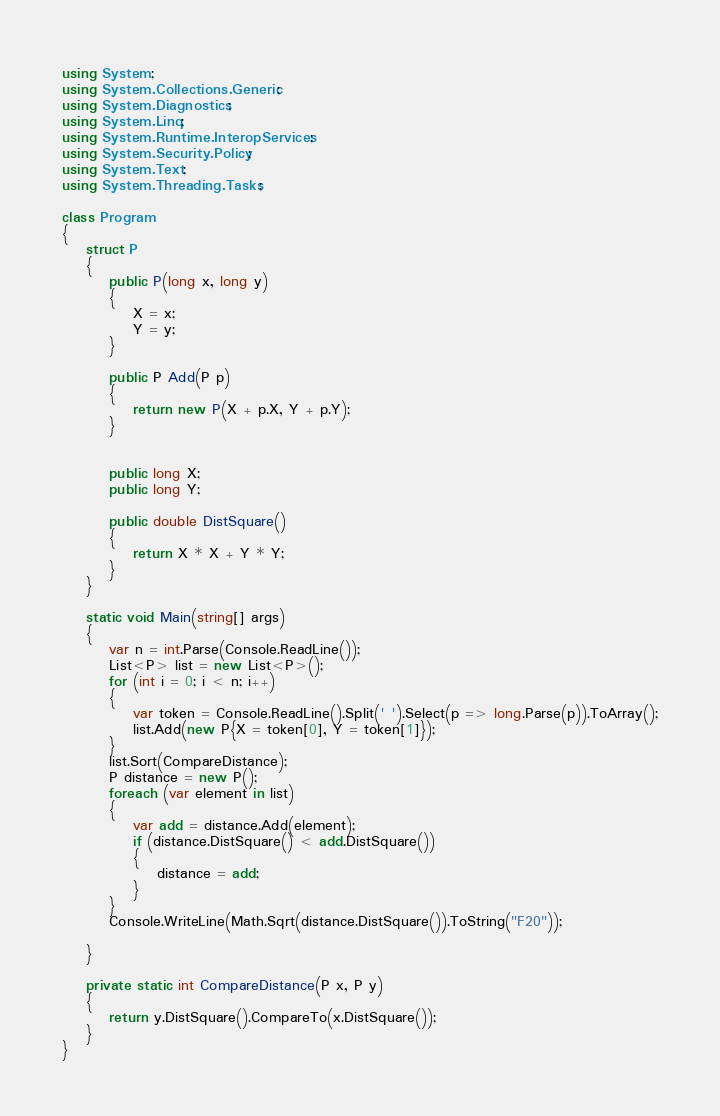<code> <loc_0><loc_0><loc_500><loc_500><_C#_>using System;
using System.Collections.Generic;
using System.Diagnostics;
using System.Linq;
using System.Runtime.InteropServices;
using System.Security.Policy;
using System.Text;
using System.Threading.Tasks;

class Program
{
    struct P
    {
        public P(long x, long y)
        {
            X = x;
            Y = y;
        }

        public P Add(P p)
        {
            return new P(X + p.X, Y + p.Y);
        }


        public long X;
        public long Y;

        public double DistSquare()
        {
            return X * X + Y * Y;
        }
    }

    static void Main(string[] args)
    {
        var n = int.Parse(Console.ReadLine());
        List<P> list = new List<P>();
        for (int i = 0; i < n; i++)
        {
            var token = Console.ReadLine().Split(' ').Select(p => long.Parse(p)).ToArray();
            list.Add(new P{X = token[0], Y = token[1]});
        }
        list.Sort(CompareDistance);
        P distance = new P();
        foreach (var element in list)
        {
            var add = distance.Add(element);
            if (distance.DistSquare() < add.DistSquare())
            {
                distance = add;
            }
        }
        Console.WriteLine(Math.Sqrt(distance.DistSquare()).ToString("F20"));

    }

    private static int CompareDistance(P x, P y)
    {
        return y.DistSquare().CompareTo(x.DistSquare());
    }
}
</code> 